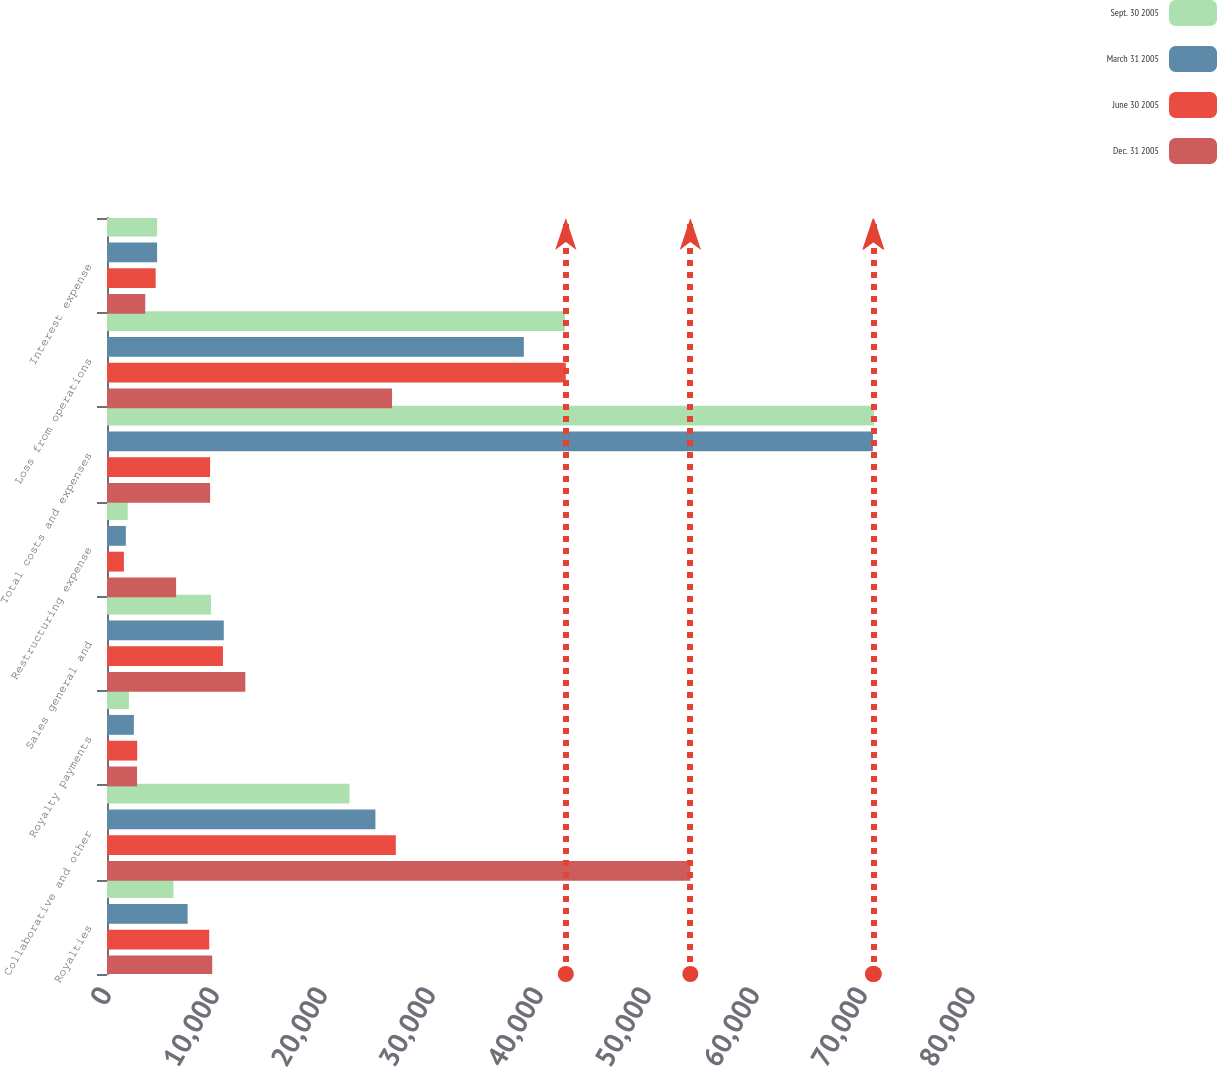Convert chart to OTSL. <chart><loc_0><loc_0><loc_500><loc_500><stacked_bar_chart><ecel><fcel>Royalties<fcel>Collaborative and other<fcel>Royalty payments<fcel>Sales general and<fcel>Restructuring expense<fcel>Total costs and expenses<fcel>Loss from operations<fcel>Interest expense<nl><fcel>Sept. 30 2005<fcel>6153<fcel>22453<fcel>2030<fcel>9627<fcel>1914<fcel>71006<fcel>42400<fcel>4639<nl><fcel>March 31 2005<fcel>7467<fcel>24854<fcel>2489<fcel>10814<fcel>1743<fcel>70917<fcel>38596<fcel>4639<nl><fcel>June 30 2005<fcel>9466<fcel>26741<fcel>2796<fcel>10738<fcel>1565<fcel>9546.5<fcel>42482<fcel>4505<nl><fcel>Dec. 31 2005<fcel>9743<fcel>54013<fcel>2783<fcel>12811<fcel>6398<fcel>9546.5<fcel>26394<fcel>3543<nl></chart> 